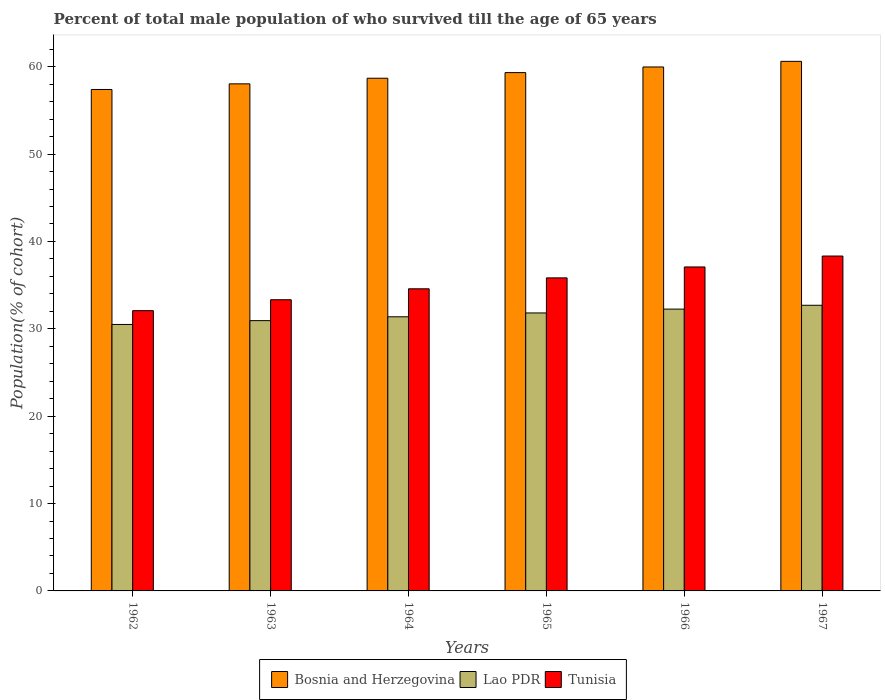How many different coloured bars are there?
Your answer should be compact. 3. How many groups of bars are there?
Offer a terse response. 6. How many bars are there on the 4th tick from the right?
Offer a terse response. 3. What is the label of the 4th group of bars from the left?
Your answer should be very brief. 1965. What is the percentage of total male population who survived till the age of 65 years in Lao PDR in 1966?
Make the answer very short. 32.25. Across all years, what is the maximum percentage of total male population who survived till the age of 65 years in Bosnia and Herzegovina?
Provide a short and direct response. 60.61. Across all years, what is the minimum percentage of total male population who survived till the age of 65 years in Lao PDR?
Provide a succinct answer. 30.5. In which year was the percentage of total male population who survived till the age of 65 years in Lao PDR maximum?
Offer a terse response. 1967. In which year was the percentage of total male population who survived till the age of 65 years in Lao PDR minimum?
Keep it short and to the point. 1962. What is the total percentage of total male population who survived till the age of 65 years in Tunisia in the graph?
Keep it short and to the point. 211.22. What is the difference between the percentage of total male population who survived till the age of 65 years in Bosnia and Herzegovina in 1963 and that in 1967?
Your answer should be compact. -2.57. What is the difference between the percentage of total male population who survived till the age of 65 years in Tunisia in 1964 and the percentage of total male population who survived till the age of 65 years in Bosnia and Herzegovina in 1967?
Your answer should be very brief. -26.03. What is the average percentage of total male population who survived till the age of 65 years in Bosnia and Herzegovina per year?
Your answer should be compact. 59. In the year 1967, what is the difference between the percentage of total male population who survived till the age of 65 years in Lao PDR and percentage of total male population who survived till the age of 65 years in Bosnia and Herzegovina?
Provide a short and direct response. -27.92. What is the ratio of the percentage of total male population who survived till the age of 65 years in Tunisia in 1964 to that in 1965?
Provide a succinct answer. 0.97. Is the percentage of total male population who survived till the age of 65 years in Bosnia and Herzegovina in 1965 less than that in 1967?
Your answer should be compact. Yes. What is the difference between the highest and the second highest percentage of total male population who survived till the age of 65 years in Bosnia and Herzegovina?
Provide a short and direct response. 0.64. What is the difference between the highest and the lowest percentage of total male population who survived till the age of 65 years in Bosnia and Herzegovina?
Give a very brief answer. 3.22. In how many years, is the percentage of total male population who survived till the age of 65 years in Tunisia greater than the average percentage of total male population who survived till the age of 65 years in Tunisia taken over all years?
Ensure brevity in your answer.  3. Is the sum of the percentage of total male population who survived till the age of 65 years in Bosnia and Herzegovina in 1963 and 1966 greater than the maximum percentage of total male population who survived till the age of 65 years in Tunisia across all years?
Your answer should be compact. Yes. What does the 3rd bar from the left in 1964 represents?
Make the answer very short. Tunisia. What does the 3rd bar from the right in 1963 represents?
Your answer should be compact. Bosnia and Herzegovina. Is it the case that in every year, the sum of the percentage of total male population who survived till the age of 65 years in Bosnia and Herzegovina and percentage of total male population who survived till the age of 65 years in Lao PDR is greater than the percentage of total male population who survived till the age of 65 years in Tunisia?
Your answer should be very brief. Yes. What is the difference between two consecutive major ticks on the Y-axis?
Your answer should be very brief. 10. Does the graph contain any zero values?
Offer a terse response. No. Where does the legend appear in the graph?
Provide a short and direct response. Bottom center. How many legend labels are there?
Your answer should be very brief. 3. How are the legend labels stacked?
Offer a very short reply. Horizontal. What is the title of the graph?
Make the answer very short. Percent of total male population of who survived till the age of 65 years. Does "Sri Lanka" appear as one of the legend labels in the graph?
Offer a very short reply. No. What is the label or title of the Y-axis?
Offer a terse response. Population(% of cohort). What is the Population(% of cohort) of Bosnia and Herzegovina in 1962?
Make the answer very short. 57.39. What is the Population(% of cohort) of Lao PDR in 1962?
Offer a terse response. 30.5. What is the Population(% of cohort) in Tunisia in 1962?
Provide a succinct answer. 32.08. What is the Population(% of cohort) in Bosnia and Herzegovina in 1963?
Ensure brevity in your answer.  58.04. What is the Population(% of cohort) in Lao PDR in 1963?
Your response must be concise. 30.94. What is the Population(% of cohort) in Tunisia in 1963?
Your response must be concise. 33.33. What is the Population(% of cohort) of Bosnia and Herzegovina in 1964?
Your answer should be compact. 58.68. What is the Population(% of cohort) of Lao PDR in 1964?
Your answer should be compact. 31.38. What is the Population(% of cohort) in Tunisia in 1964?
Your answer should be very brief. 34.58. What is the Population(% of cohort) of Bosnia and Herzegovina in 1965?
Make the answer very short. 59.32. What is the Population(% of cohort) in Lao PDR in 1965?
Ensure brevity in your answer.  31.81. What is the Population(% of cohort) in Tunisia in 1965?
Ensure brevity in your answer.  35.83. What is the Population(% of cohort) in Bosnia and Herzegovina in 1966?
Give a very brief answer. 59.97. What is the Population(% of cohort) in Lao PDR in 1966?
Give a very brief answer. 32.25. What is the Population(% of cohort) in Tunisia in 1966?
Ensure brevity in your answer.  37.08. What is the Population(% of cohort) in Bosnia and Herzegovina in 1967?
Give a very brief answer. 60.61. What is the Population(% of cohort) of Lao PDR in 1967?
Provide a short and direct response. 32.69. What is the Population(% of cohort) in Tunisia in 1967?
Ensure brevity in your answer.  38.33. Across all years, what is the maximum Population(% of cohort) of Bosnia and Herzegovina?
Your response must be concise. 60.61. Across all years, what is the maximum Population(% of cohort) of Lao PDR?
Your answer should be very brief. 32.69. Across all years, what is the maximum Population(% of cohort) in Tunisia?
Provide a short and direct response. 38.33. Across all years, what is the minimum Population(% of cohort) in Bosnia and Herzegovina?
Provide a short and direct response. 57.39. Across all years, what is the minimum Population(% of cohort) of Lao PDR?
Give a very brief answer. 30.5. Across all years, what is the minimum Population(% of cohort) in Tunisia?
Your answer should be very brief. 32.08. What is the total Population(% of cohort) in Bosnia and Herzegovina in the graph?
Your answer should be compact. 354.01. What is the total Population(% of cohort) in Lao PDR in the graph?
Offer a terse response. 189.57. What is the total Population(% of cohort) in Tunisia in the graph?
Give a very brief answer. 211.22. What is the difference between the Population(% of cohort) of Bosnia and Herzegovina in 1962 and that in 1963?
Ensure brevity in your answer.  -0.64. What is the difference between the Population(% of cohort) of Lao PDR in 1962 and that in 1963?
Your answer should be very brief. -0.44. What is the difference between the Population(% of cohort) in Tunisia in 1962 and that in 1963?
Your response must be concise. -1.25. What is the difference between the Population(% of cohort) in Bosnia and Herzegovina in 1962 and that in 1964?
Keep it short and to the point. -1.29. What is the difference between the Population(% of cohort) in Lao PDR in 1962 and that in 1964?
Provide a succinct answer. -0.88. What is the difference between the Population(% of cohort) of Tunisia in 1962 and that in 1964?
Your response must be concise. -2.5. What is the difference between the Population(% of cohort) in Bosnia and Herzegovina in 1962 and that in 1965?
Your answer should be very brief. -1.93. What is the difference between the Population(% of cohort) in Lao PDR in 1962 and that in 1965?
Your answer should be very brief. -1.32. What is the difference between the Population(% of cohort) in Tunisia in 1962 and that in 1965?
Give a very brief answer. -3.75. What is the difference between the Population(% of cohort) in Bosnia and Herzegovina in 1962 and that in 1966?
Make the answer very short. -2.57. What is the difference between the Population(% of cohort) of Lao PDR in 1962 and that in 1966?
Give a very brief answer. -1.76. What is the difference between the Population(% of cohort) in Tunisia in 1962 and that in 1966?
Provide a short and direct response. -5. What is the difference between the Population(% of cohort) in Bosnia and Herzegovina in 1962 and that in 1967?
Your answer should be compact. -3.22. What is the difference between the Population(% of cohort) in Lao PDR in 1962 and that in 1967?
Your answer should be compact. -2.2. What is the difference between the Population(% of cohort) of Tunisia in 1962 and that in 1967?
Keep it short and to the point. -6.25. What is the difference between the Population(% of cohort) of Bosnia and Herzegovina in 1963 and that in 1964?
Provide a short and direct response. -0.64. What is the difference between the Population(% of cohort) of Lao PDR in 1963 and that in 1964?
Make the answer very short. -0.44. What is the difference between the Population(% of cohort) in Tunisia in 1963 and that in 1964?
Provide a short and direct response. -1.25. What is the difference between the Population(% of cohort) of Bosnia and Herzegovina in 1963 and that in 1965?
Ensure brevity in your answer.  -1.29. What is the difference between the Population(% of cohort) of Lao PDR in 1963 and that in 1965?
Your answer should be very brief. -0.88. What is the difference between the Population(% of cohort) in Tunisia in 1963 and that in 1965?
Provide a short and direct response. -2.5. What is the difference between the Population(% of cohort) in Bosnia and Herzegovina in 1963 and that in 1966?
Keep it short and to the point. -1.93. What is the difference between the Population(% of cohort) of Lao PDR in 1963 and that in 1966?
Offer a terse response. -1.32. What is the difference between the Population(% of cohort) of Tunisia in 1963 and that in 1966?
Make the answer very short. -3.75. What is the difference between the Population(% of cohort) in Bosnia and Herzegovina in 1963 and that in 1967?
Your answer should be very brief. -2.57. What is the difference between the Population(% of cohort) in Lao PDR in 1963 and that in 1967?
Provide a succinct answer. -1.76. What is the difference between the Population(% of cohort) of Tunisia in 1963 and that in 1967?
Keep it short and to the point. -5. What is the difference between the Population(% of cohort) in Bosnia and Herzegovina in 1964 and that in 1965?
Make the answer very short. -0.64. What is the difference between the Population(% of cohort) in Lao PDR in 1964 and that in 1965?
Provide a succinct answer. -0.44. What is the difference between the Population(% of cohort) of Tunisia in 1964 and that in 1965?
Offer a very short reply. -1.25. What is the difference between the Population(% of cohort) in Bosnia and Herzegovina in 1964 and that in 1966?
Provide a short and direct response. -1.29. What is the difference between the Population(% of cohort) of Lao PDR in 1964 and that in 1966?
Your answer should be compact. -0.88. What is the difference between the Population(% of cohort) of Tunisia in 1964 and that in 1966?
Offer a terse response. -2.5. What is the difference between the Population(% of cohort) in Bosnia and Herzegovina in 1964 and that in 1967?
Provide a succinct answer. -1.93. What is the difference between the Population(% of cohort) in Lao PDR in 1964 and that in 1967?
Give a very brief answer. -1.32. What is the difference between the Population(% of cohort) in Tunisia in 1964 and that in 1967?
Your response must be concise. -3.75. What is the difference between the Population(% of cohort) in Bosnia and Herzegovina in 1965 and that in 1966?
Offer a very short reply. -0.64. What is the difference between the Population(% of cohort) of Lao PDR in 1965 and that in 1966?
Give a very brief answer. -0.44. What is the difference between the Population(% of cohort) in Tunisia in 1965 and that in 1966?
Your answer should be very brief. -1.25. What is the difference between the Population(% of cohort) of Bosnia and Herzegovina in 1965 and that in 1967?
Offer a very short reply. -1.29. What is the difference between the Population(% of cohort) of Lao PDR in 1965 and that in 1967?
Offer a terse response. -0.88. What is the difference between the Population(% of cohort) in Tunisia in 1965 and that in 1967?
Make the answer very short. -2.5. What is the difference between the Population(% of cohort) of Bosnia and Herzegovina in 1966 and that in 1967?
Keep it short and to the point. -0.64. What is the difference between the Population(% of cohort) of Lao PDR in 1966 and that in 1967?
Ensure brevity in your answer.  -0.44. What is the difference between the Population(% of cohort) of Tunisia in 1966 and that in 1967?
Provide a short and direct response. -1.25. What is the difference between the Population(% of cohort) in Bosnia and Herzegovina in 1962 and the Population(% of cohort) in Lao PDR in 1963?
Ensure brevity in your answer.  26.46. What is the difference between the Population(% of cohort) in Bosnia and Herzegovina in 1962 and the Population(% of cohort) in Tunisia in 1963?
Make the answer very short. 24.07. What is the difference between the Population(% of cohort) of Lao PDR in 1962 and the Population(% of cohort) of Tunisia in 1963?
Provide a succinct answer. -2.83. What is the difference between the Population(% of cohort) in Bosnia and Herzegovina in 1962 and the Population(% of cohort) in Lao PDR in 1964?
Offer a very short reply. 26.02. What is the difference between the Population(% of cohort) in Bosnia and Herzegovina in 1962 and the Population(% of cohort) in Tunisia in 1964?
Your answer should be compact. 22.82. What is the difference between the Population(% of cohort) of Lao PDR in 1962 and the Population(% of cohort) of Tunisia in 1964?
Provide a succinct answer. -4.08. What is the difference between the Population(% of cohort) in Bosnia and Herzegovina in 1962 and the Population(% of cohort) in Lao PDR in 1965?
Keep it short and to the point. 25.58. What is the difference between the Population(% of cohort) in Bosnia and Herzegovina in 1962 and the Population(% of cohort) in Tunisia in 1965?
Offer a terse response. 21.56. What is the difference between the Population(% of cohort) in Lao PDR in 1962 and the Population(% of cohort) in Tunisia in 1965?
Offer a very short reply. -5.33. What is the difference between the Population(% of cohort) of Bosnia and Herzegovina in 1962 and the Population(% of cohort) of Lao PDR in 1966?
Give a very brief answer. 25.14. What is the difference between the Population(% of cohort) of Bosnia and Herzegovina in 1962 and the Population(% of cohort) of Tunisia in 1966?
Provide a short and direct response. 20.31. What is the difference between the Population(% of cohort) in Lao PDR in 1962 and the Population(% of cohort) in Tunisia in 1966?
Make the answer very short. -6.58. What is the difference between the Population(% of cohort) in Bosnia and Herzegovina in 1962 and the Population(% of cohort) in Lao PDR in 1967?
Your answer should be very brief. 24.7. What is the difference between the Population(% of cohort) of Bosnia and Herzegovina in 1962 and the Population(% of cohort) of Tunisia in 1967?
Offer a very short reply. 19.06. What is the difference between the Population(% of cohort) of Lao PDR in 1962 and the Population(% of cohort) of Tunisia in 1967?
Keep it short and to the point. -7.83. What is the difference between the Population(% of cohort) in Bosnia and Herzegovina in 1963 and the Population(% of cohort) in Lao PDR in 1964?
Your answer should be compact. 26.66. What is the difference between the Population(% of cohort) in Bosnia and Herzegovina in 1963 and the Population(% of cohort) in Tunisia in 1964?
Your answer should be compact. 23.46. What is the difference between the Population(% of cohort) of Lao PDR in 1963 and the Population(% of cohort) of Tunisia in 1964?
Your answer should be compact. -3.64. What is the difference between the Population(% of cohort) of Bosnia and Herzegovina in 1963 and the Population(% of cohort) of Lao PDR in 1965?
Make the answer very short. 26.22. What is the difference between the Population(% of cohort) of Bosnia and Herzegovina in 1963 and the Population(% of cohort) of Tunisia in 1965?
Your answer should be compact. 22.21. What is the difference between the Population(% of cohort) in Lao PDR in 1963 and the Population(% of cohort) in Tunisia in 1965?
Your answer should be very brief. -4.89. What is the difference between the Population(% of cohort) of Bosnia and Herzegovina in 1963 and the Population(% of cohort) of Lao PDR in 1966?
Offer a terse response. 25.78. What is the difference between the Population(% of cohort) of Bosnia and Herzegovina in 1963 and the Population(% of cohort) of Tunisia in 1966?
Provide a succinct answer. 20.96. What is the difference between the Population(% of cohort) of Lao PDR in 1963 and the Population(% of cohort) of Tunisia in 1966?
Provide a short and direct response. -6.14. What is the difference between the Population(% of cohort) of Bosnia and Herzegovina in 1963 and the Population(% of cohort) of Lao PDR in 1967?
Keep it short and to the point. 25.34. What is the difference between the Population(% of cohort) in Bosnia and Herzegovina in 1963 and the Population(% of cohort) in Tunisia in 1967?
Your response must be concise. 19.71. What is the difference between the Population(% of cohort) of Lao PDR in 1963 and the Population(% of cohort) of Tunisia in 1967?
Offer a terse response. -7.39. What is the difference between the Population(% of cohort) of Bosnia and Herzegovina in 1964 and the Population(% of cohort) of Lao PDR in 1965?
Ensure brevity in your answer.  26.86. What is the difference between the Population(% of cohort) in Bosnia and Herzegovina in 1964 and the Population(% of cohort) in Tunisia in 1965?
Offer a terse response. 22.85. What is the difference between the Population(% of cohort) of Lao PDR in 1964 and the Population(% of cohort) of Tunisia in 1965?
Give a very brief answer. -4.45. What is the difference between the Population(% of cohort) of Bosnia and Herzegovina in 1964 and the Population(% of cohort) of Lao PDR in 1966?
Your answer should be compact. 26.43. What is the difference between the Population(% of cohort) in Bosnia and Herzegovina in 1964 and the Population(% of cohort) in Tunisia in 1966?
Your answer should be compact. 21.6. What is the difference between the Population(% of cohort) in Lao PDR in 1964 and the Population(% of cohort) in Tunisia in 1966?
Your response must be concise. -5.7. What is the difference between the Population(% of cohort) in Bosnia and Herzegovina in 1964 and the Population(% of cohort) in Lao PDR in 1967?
Offer a terse response. 25.99. What is the difference between the Population(% of cohort) in Bosnia and Herzegovina in 1964 and the Population(% of cohort) in Tunisia in 1967?
Your answer should be compact. 20.35. What is the difference between the Population(% of cohort) of Lao PDR in 1964 and the Population(% of cohort) of Tunisia in 1967?
Give a very brief answer. -6.95. What is the difference between the Population(% of cohort) of Bosnia and Herzegovina in 1965 and the Population(% of cohort) of Lao PDR in 1966?
Offer a very short reply. 27.07. What is the difference between the Population(% of cohort) of Bosnia and Herzegovina in 1965 and the Population(% of cohort) of Tunisia in 1966?
Provide a succinct answer. 22.25. What is the difference between the Population(% of cohort) of Lao PDR in 1965 and the Population(% of cohort) of Tunisia in 1966?
Offer a terse response. -5.26. What is the difference between the Population(% of cohort) of Bosnia and Herzegovina in 1965 and the Population(% of cohort) of Lao PDR in 1967?
Your answer should be compact. 26.63. What is the difference between the Population(% of cohort) in Bosnia and Herzegovina in 1965 and the Population(% of cohort) in Tunisia in 1967?
Make the answer very short. 20.99. What is the difference between the Population(% of cohort) of Lao PDR in 1965 and the Population(% of cohort) of Tunisia in 1967?
Give a very brief answer. -6.51. What is the difference between the Population(% of cohort) of Bosnia and Herzegovina in 1966 and the Population(% of cohort) of Lao PDR in 1967?
Provide a succinct answer. 27.27. What is the difference between the Population(% of cohort) of Bosnia and Herzegovina in 1966 and the Population(% of cohort) of Tunisia in 1967?
Offer a very short reply. 21.64. What is the difference between the Population(% of cohort) of Lao PDR in 1966 and the Population(% of cohort) of Tunisia in 1967?
Offer a terse response. -6.07. What is the average Population(% of cohort) of Bosnia and Herzegovina per year?
Make the answer very short. 59. What is the average Population(% of cohort) in Lao PDR per year?
Offer a very short reply. 31.6. What is the average Population(% of cohort) of Tunisia per year?
Offer a very short reply. 35.2. In the year 1962, what is the difference between the Population(% of cohort) in Bosnia and Herzegovina and Population(% of cohort) in Lao PDR?
Give a very brief answer. 26.9. In the year 1962, what is the difference between the Population(% of cohort) in Bosnia and Herzegovina and Population(% of cohort) in Tunisia?
Provide a short and direct response. 25.32. In the year 1962, what is the difference between the Population(% of cohort) of Lao PDR and Population(% of cohort) of Tunisia?
Give a very brief answer. -1.58. In the year 1963, what is the difference between the Population(% of cohort) of Bosnia and Herzegovina and Population(% of cohort) of Lao PDR?
Keep it short and to the point. 27.1. In the year 1963, what is the difference between the Population(% of cohort) of Bosnia and Herzegovina and Population(% of cohort) of Tunisia?
Your response must be concise. 24.71. In the year 1963, what is the difference between the Population(% of cohort) in Lao PDR and Population(% of cohort) in Tunisia?
Provide a succinct answer. -2.39. In the year 1964, what is the difference between the Population(% of cohort) of Bosnia and Herzegovina and Population(% of cohort) of Lao PDR?
Make the answer very short. 27.3. In the year 1964, what is the difference between the Population(% of cohort) of Bosnia and Herzegovina and Population(% of cohort) of Tunisia?
Provide a succinct answer. 24.1. In the year 1964, what is the difference between the Population(% of cohort) of Lao PDR and Population(% of cohort) of Tunisia?
Give a very brief answer. -3.2. In the year 1965, what is the difference between the Population(% of cohort) in Bosnia and Herzegovina and Population(% of cohort) in Lao PDR?
Provide a short and direct response. 27.51. In the year 1965, what is the difference between the Population(% of cohort) of Bosnia and Herzegovina and Population(% of cohort) of Tunisia?
Your answer should be very brief. 23.5. In the year 1965, what is the difference between the Population(% of cohort) of Lao PDR and Population(% of cohort) of Tunisia?
Your answer should be very brief. -4.01. In the year 1966, what is the difference between the Population(% of cohort) in Bosnia and Herzegovina and Population(% of cohort) in Lao PDR?
Give a very brief answer. 27.71. In the year 1966, what is the difference between the Population(% of cohort) of Bosnia and Herzegovina and Population(% of cohort) of Tunisia?
Keep it short and to the point. 22.89. In the year 1966, what is the difference between the Population(% of cohort) of Lao PDR and Population(% of cohort) of Tunisia?
Provide a succinct answer. -4.82. In the year 1967, what is the difference between the Population(% of cohort) in Bosnia and Herzegovina and Population(% of cohort) in Lao PDR?
Your answer should be very brief. 27.92. In the year 1967, what is the difference between the Population(% of cohort) of Bosnia and Herzegovina and Population(% of cohort) of Tunisia?
Make the answer very short. 22.28. In the year 1967, what is the difference between the Population(% of cohort) in Lao PDR and Population(% of cohort) in Tunisia?
Keep it short and to the point. -5.64. What is the ratio of the Population(% of cohort) in Bosnia and Herzegovina in 1962 to that in 1963?
Offer a very short reply. 0.99. What is the ratio of the Population(% of cohort) of Lao PDR in 1962 to that in 1963?
Your answer should be very brief. 0.99. What is the ratio of the Population(% of cohort) of Tunisia in 1962 to that in 1963?
Your answer should be compact. 0.96. What is the ratio of the Population(% of cohort) of Bosnia and Herzegovina in 1962 to that in 1964?
Your answer should be compact. 0.98. What is the ratio of the Population(% of cohort) in Lao PDR in 1962 to that in 1964?
Make the answer very short. 0.97. What is the ratio of the Population(% of cohort) in Tunisia in 1962 to that in 1964?
Make the answer very short. 0.93. What is the ratio of the Population(% of cohort) of Bosnia and Herzegovina in 1962 to that in 1965?
Your answer should be very brief. 0.97. What is the ratio of the Population(% of cohort) in Lao PDR in 1962 to that in 1965?
Offer a very short reply. 0.96. What is the ratio of the Population(% of cohort) in Tunisia in 1962 to that in 1965?
Your response must be concise. 0.9. What is the ratio of the Population(% of cohort) of Bosnia and Herzegovina in 1962 to that in 1966?
Provide a succinct answer. 0.96. What is the ratio of the Population(% of cohort) of Lao PDR in 1962 to that in 1966?
Your answer should be compact. 0.95. What is the ratio of the Population(% of cohort) of Tunisia in 1962 to that in 1966?
Give a very brief answer. 0.87. What is the ratio of the Population(% of cohort) in Bosnia and Herzegovina in 1962 to that in 1967?
Give a very brief answer. 0.95. What is the ratio of the Population(% of cohort) of Lao PDR in 1962 to that in 1967?
Your response must be concise. 0.93. What is the ratio of the Population(% of cohort) of Tunisia in 1962 to that in 1967?
Your answer should be very brief. 0.84. What is the ratio of the Population(% of cohort) in Tunisia in 1963 to that in 1964?
Keep it short and to the point. 0.96. What is the ratio of the Population(% of cohort) of Bosnia and Herzegovina in 1963 to that in 1965?
Your answer should be very brief. 0.98. What is the ratio of the Population(% of cohort) of Lao PDR in 1963 to that in 1965?
Your response must be concise. 0.97. What is the ratio of the Population(% of cohort) in Tunisia in 1963 to that in 1965?
Ensure brevity in your answer.  0.93. What is the ratio of the Population(% of cohort) in Bosnia and Herzegovina in 1963 to that in 1966?
Keep it short and to the point. 0.97. What is the ratio of the Population(% of cohort) in Lao PDR in 1963 to that in 1966?
Your answer should be very brief. 0.96. What is the ratio of the Population(% of cohort) of Tunisia in 1963 to that in 1966?
Give a very brief answer. 0.9. What is the ratio of the Population(% of cohort) of Bosnia and Herzegovina in 1963 to that in 1967?
Give a very brief answer. 0.96. What is the ratio of the Population(% of cohort) in Lao PDR in 1963 to that in 1967?
Make the answer very short. 0.95. What is the ratio of the Population(% of cohort) of Tunisia in 1963 to that in 1967?
Your answer should be compact. 0.87. What is the ratio of the Population(% of cohort) in Lao PDR in 1964 to that in 1965?
Keep it short and to the point. 0.99. What is the ratio of the Population(% of cohort) of Tunisia in 1964 to that in 1965?
Your answer should be very brief. 0.97. What is the ratio of the Population(% of cohort) of Bosnia and Herzegovina in 1964 to that in 1966?
Your answer should be compact. 0.98. What is the ratio of the Population(% of cohort) in Lao PDR in 1964 to that in 1966?
Keep it short and to the point. 0.97. What is the ratio of the Population(% of cohort) in Tunisia in 1964 to that in 1966?
Give a very brief answer. 0.93. What is the ratio of the Population(% of cohort) in Bosnia and Herzegovina in 1964 to that in 1967?
Provide a short and direct response. 0.97. What is the ratio of the Population(% of cohort) of Lao PDR in 1964 to that in 1967?
Ensure brevity in your answer.  0.96. What is the ratio of the Population(% of cohort) in Tunisia in 1964 to that in 1967?
Offer a terse response. 0.9. What is the ratio of the Population(% of cohort) in Bosnia and Herzegovina in 1965 to that in 1966?
Give a very brief answer. 0.99. What is the ratio of the Population(% of cohort) in Lao PDR in 1965 to that in 1966?
Your answer should be compact. 0.99. What is the ratio of the Population(% of cohort) of Tunisia in 1965 to that in 1966?
Provide a short and direct response. 0.97. What is the ratio of the Population(% of cohort) in Bosnia and Herzegovina in 1965 to that in 1967?
Your answer should be very brief. 0.98. What is the ratio of the Population(% of cohort) of Lao PDR in 1965 to that in 1967?
Provide a succinct answer. 0.97. What is the ratio of the Population(% of cohort) of Tunisia in 1965 to that in 1967?
Keep it short and to the point. 0.93. What is the ratio of the Population(% of cohort) of Bosnia and Herzegovina in 1966 to that in 1967?
Your answer should be very brief. 0.99. What is the ratio of the Population(% of cohort) in Lao PDR in 1966 to that in 1967?
Offer a very short reply. 0.99. What is the ratio of the Population(% of cohort) in Tunisia in 1966 to that in 1967?
Your answer should be compact. 0.97. What is the difference between the highest and the second highest Population(% of cohort) in Bosnia and Herzegovina?
Offer a very short reply. 0.64. What is the difference between the highest and the second highest Population(% of cohort) of Lao PDR?
Make the answer very short. 0.44. What is the difference between the highest and the second highest Population(% of cohort) of Tunisia?
Your answer should be very brief. 1.25. What is the difference between the highest and the lowest Population(% of cohort) of Bosnia and Herzegovina?
Offer a very short reply. 3.22. What is the difference between the highest and the lowest Population(% of cohort) of Lao PDR?
Provide a succinct answer. 2.2. What is the difference between the highest and the lowest Population(% of cohort) of Tunisia?
Ensure brevity in your answer.  6.25. 